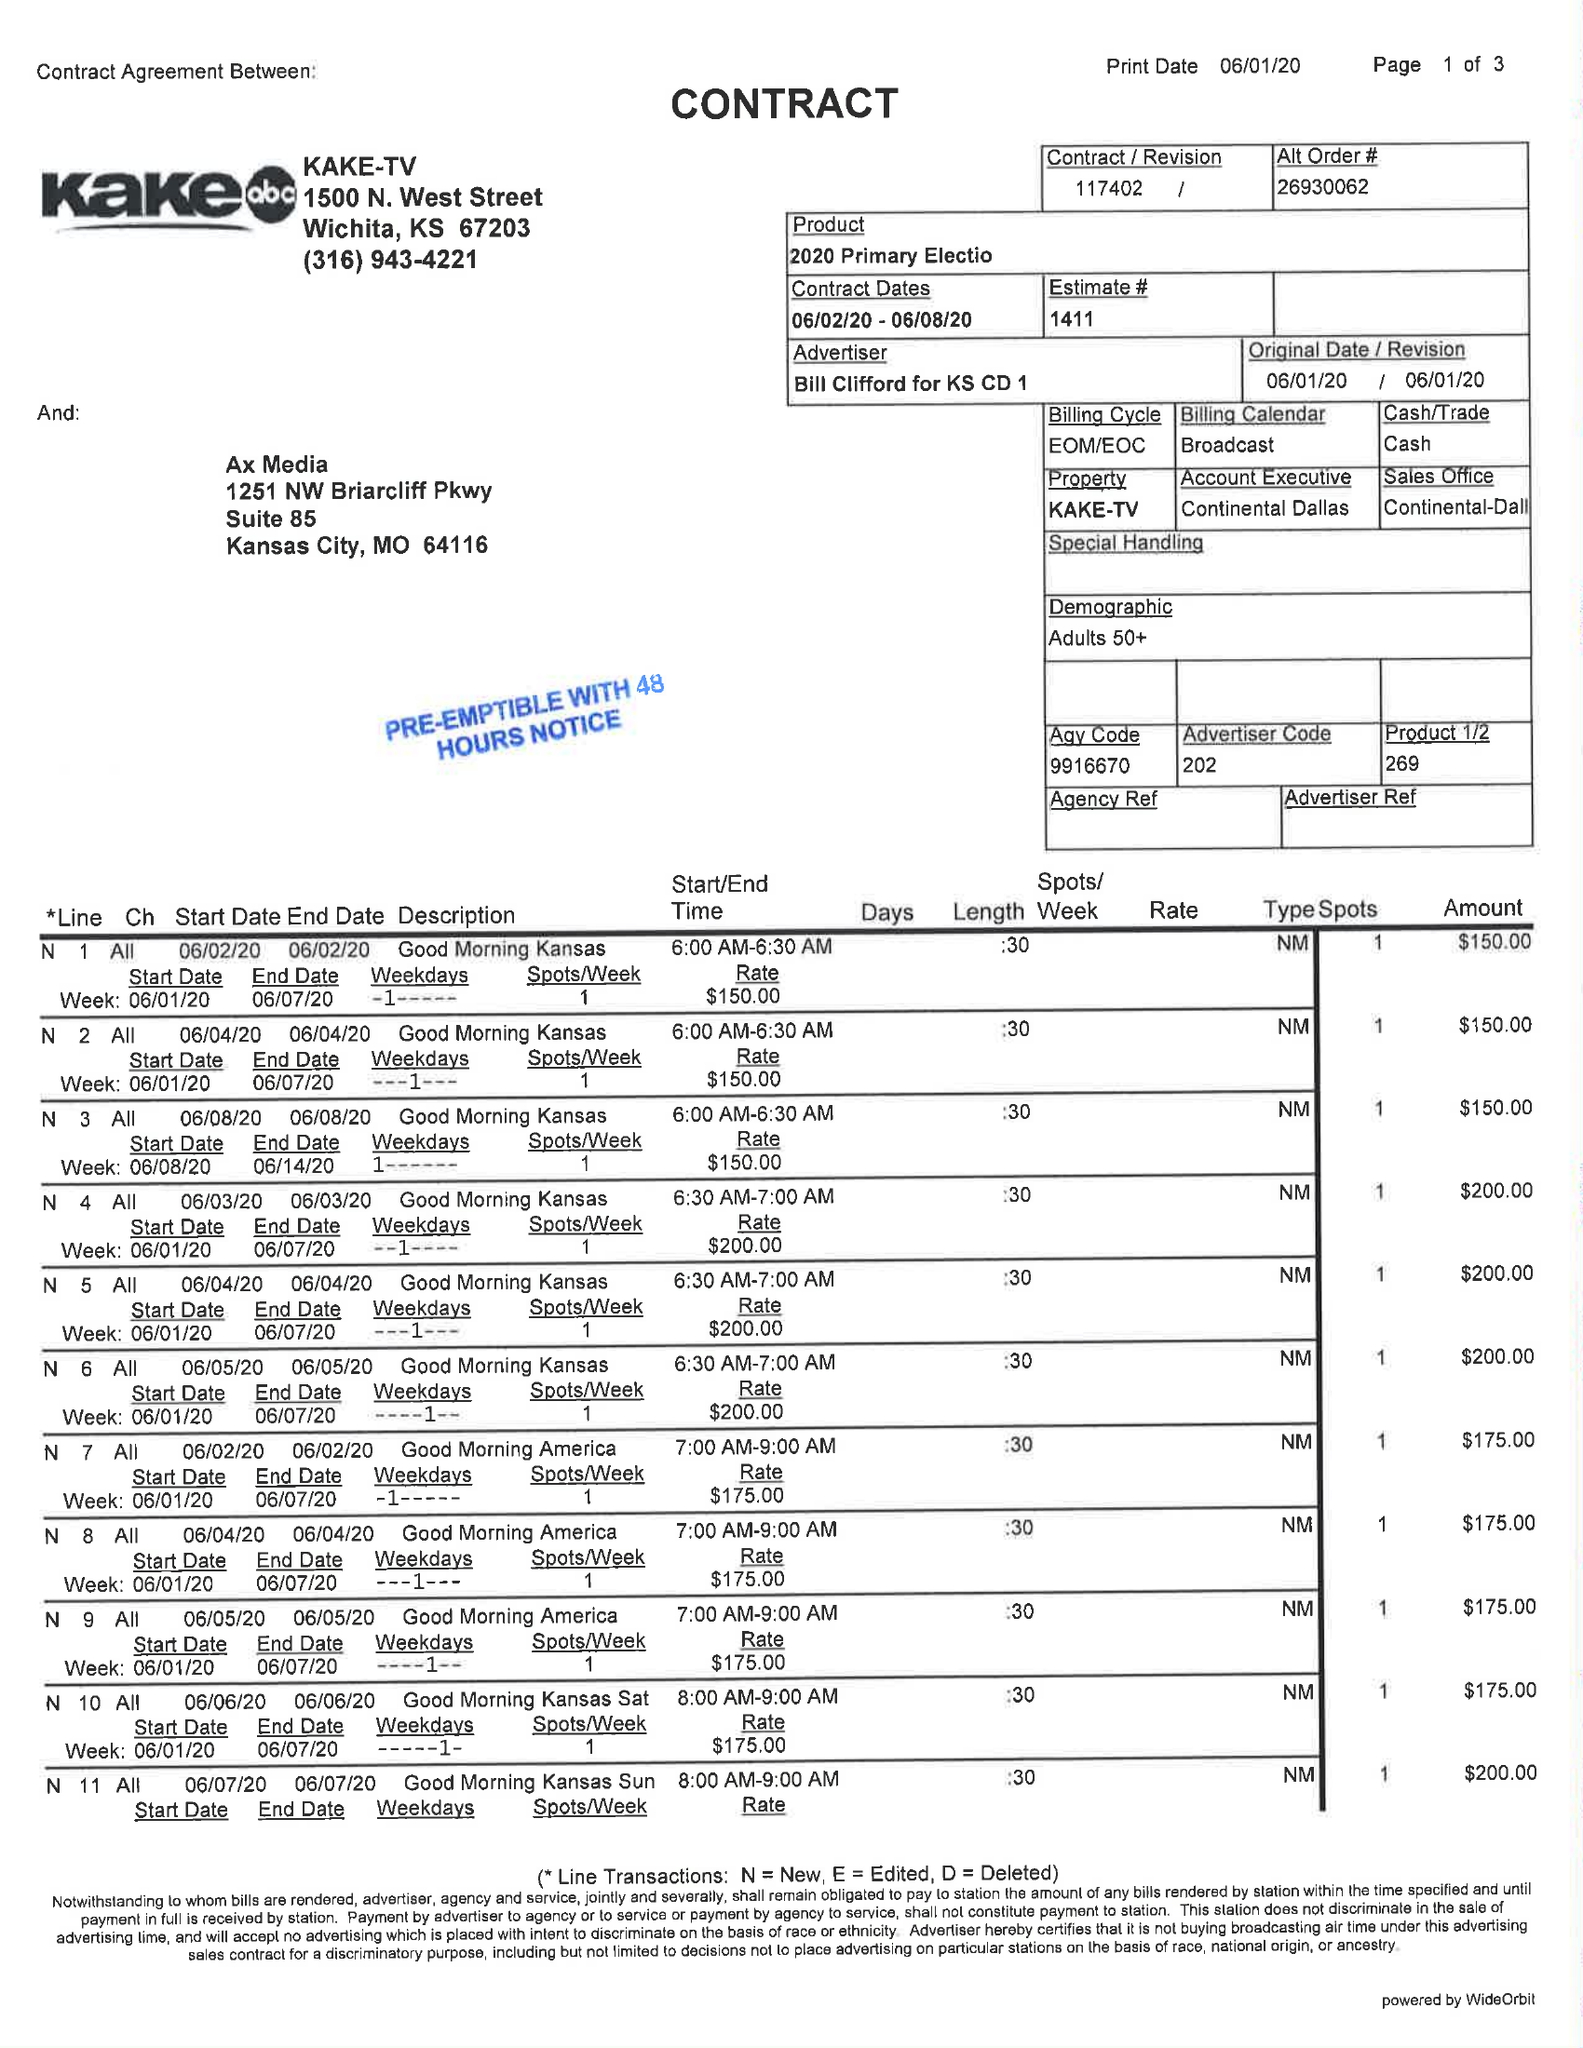What is the value for the contract_num?
Answer the question using a single word or phrase. 117402 